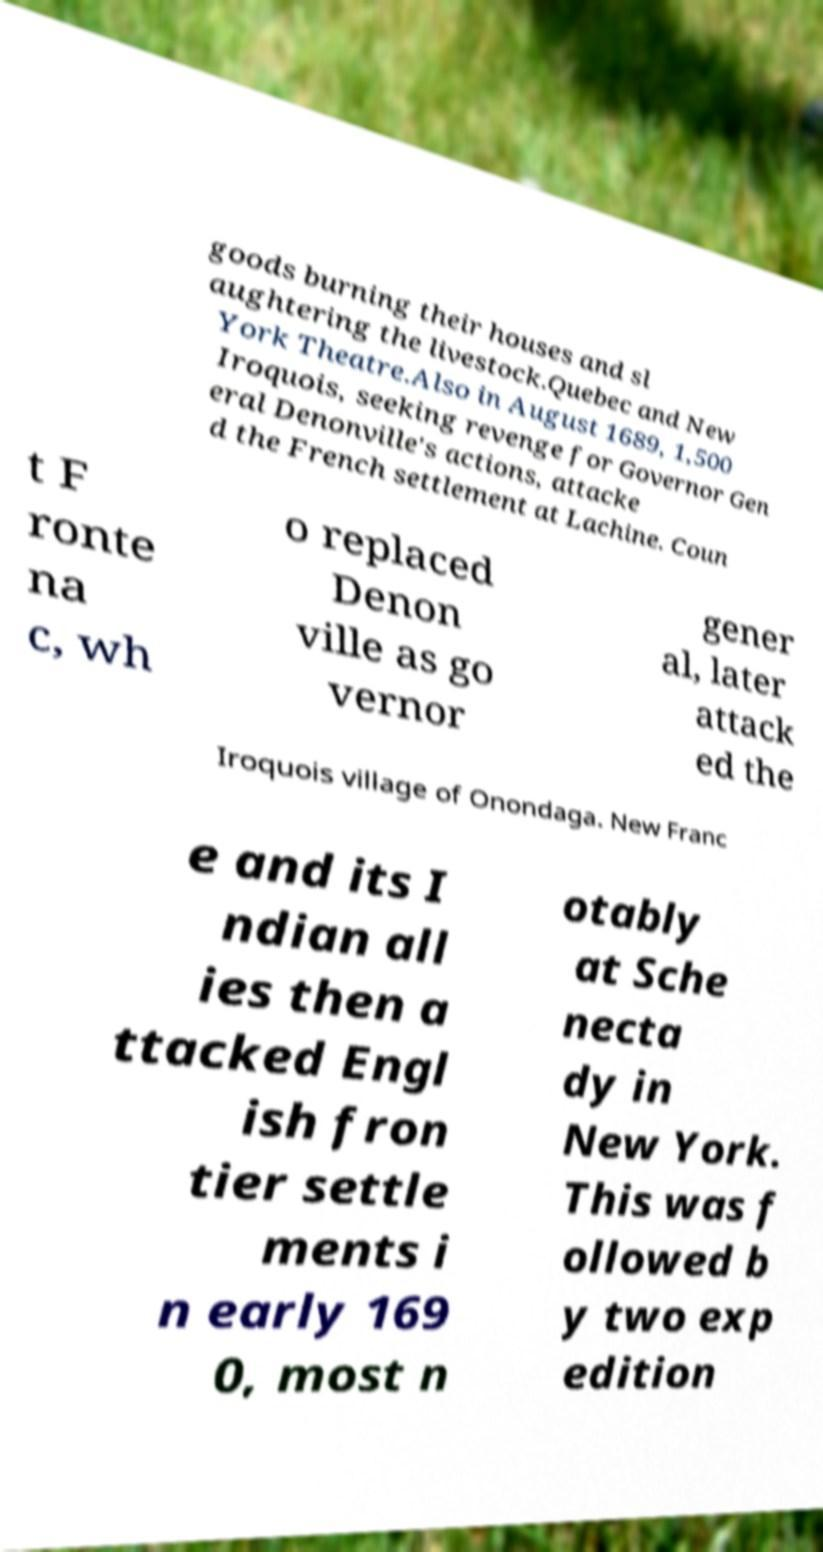For documentation purposes, I need the text within this image transcribed. Could you provide that? goods burning their houses and sl aughtering the livestock.Quebec and New York Theatre.Also in August 1689, 1,500 Iroquois, seeking revenge for Governor Gen eral Denonville's actions, attacke d the French settlement at Lachine. Coun t F ronte na c, wh o replaced Denon ville as go vernor gener al, later attack ed the Iroquois village of Onondaga. New Franc e and its I ndian all ies then a ttacked Engl ish fron tier settle ments i n early 169 0, most n otably at Sche necta dy in New York. This was f ollowed b y two exp edition 